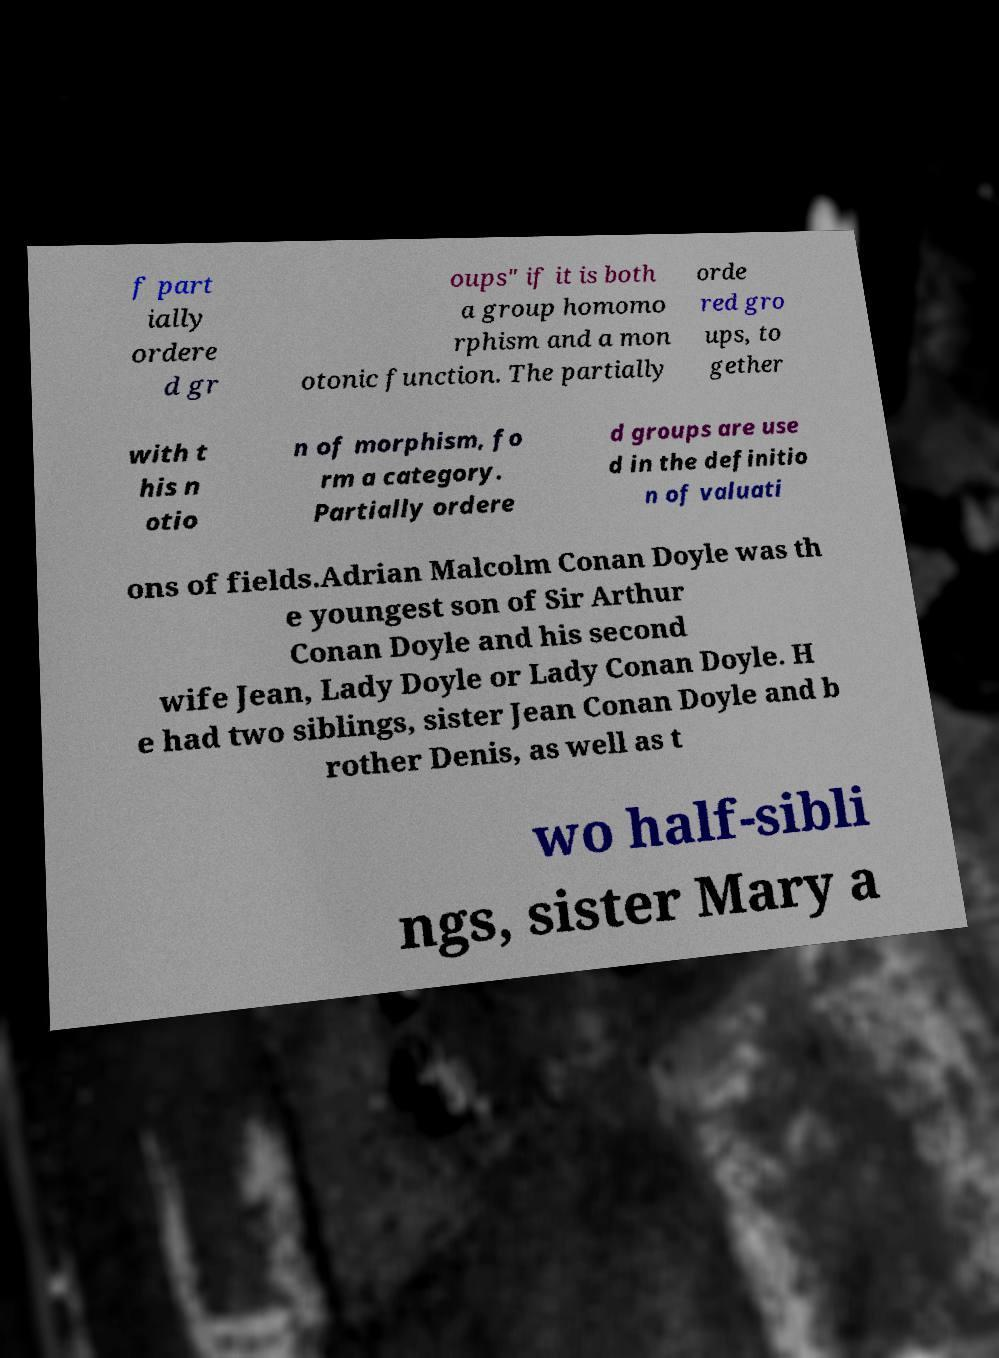For documentation purposes, I need the text within this image transcribed. Could you provide that? f part ially ordere d gr oups" if it is both a group homomo rphism and a mon otonic function. The partially orde red gro ups, to gether with t his n otio n of morphism, fo rm a category. Partially ordere d groups are use d in the definitio n of valuati ons of fields.Adrian Malcolm Conan Doyle was th e youngest son of Sir Arthur Conan Doyle and his second wife Jean, Lady Doyle or Lady Conan Doyle. H e had two siblings, sister Jean Conan Doyle and b rother Denis, as well as t wo half-sibli ngs, sister Mary a 